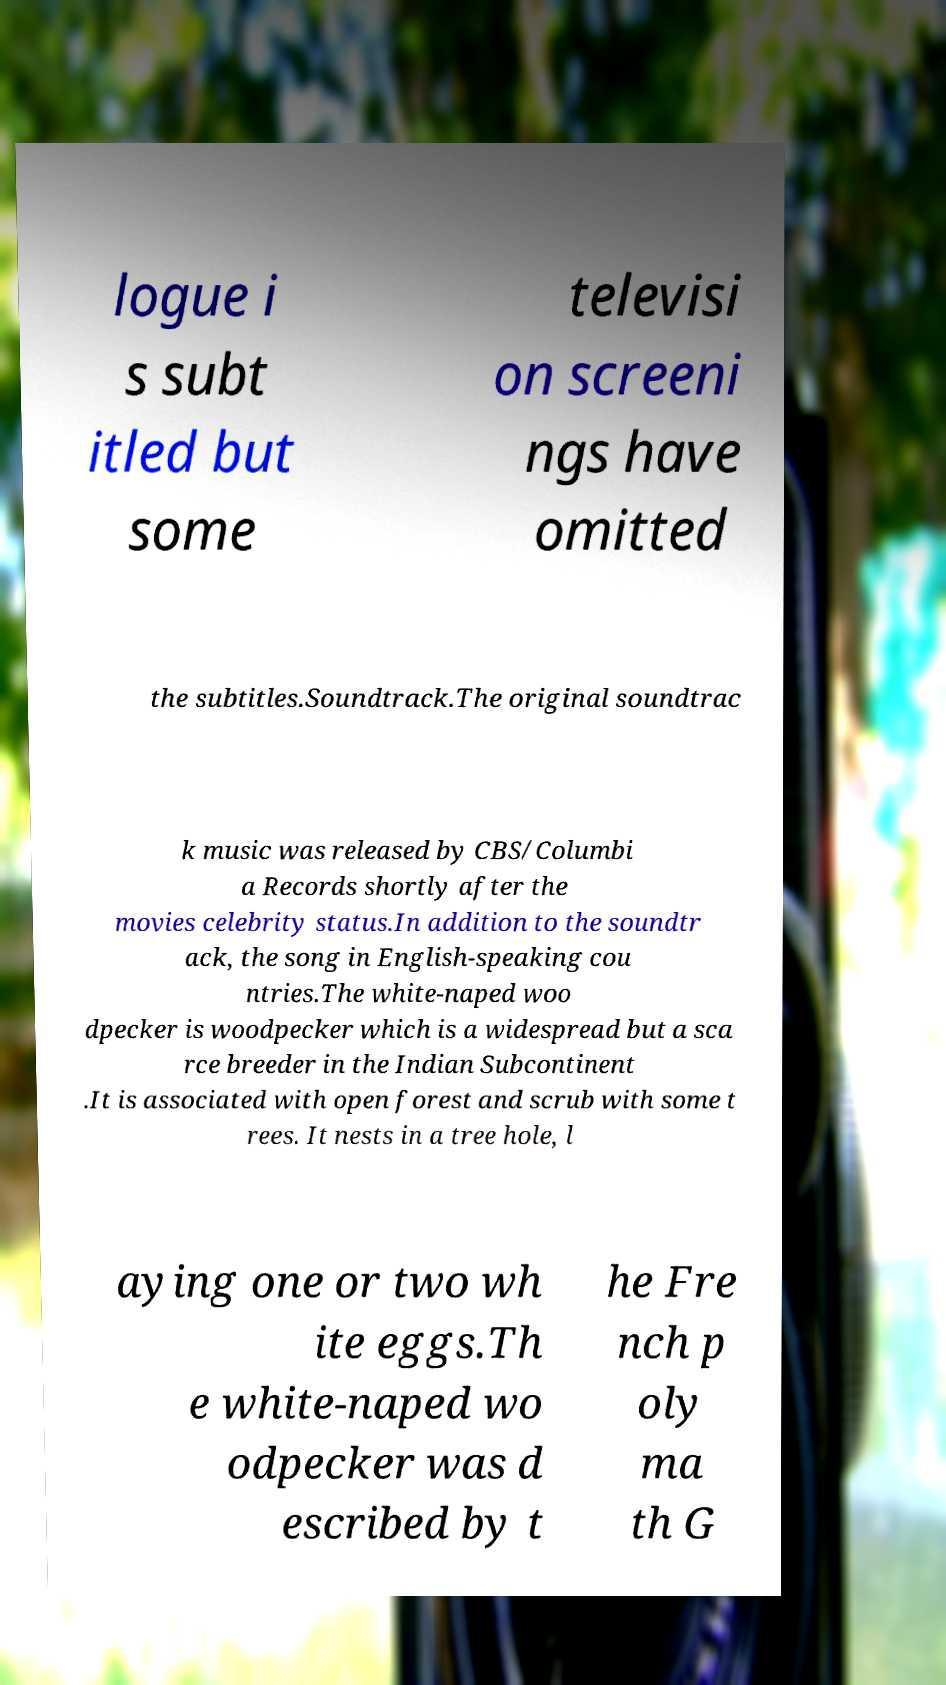Please identify and transcribe the text found in this image. logue i s subt itled but some televisi on screeni ngs have omitted the subtitles.Soundtrack.The original soundtrac k music was released by CBS/Columbi a Records shortly after the movies celebrity status.In addition to the soundtr ack, the song in English-speaking cou ntries.The white-naped woo dpecker is woodpecker which is a widespread but a sca rce breeder in the Indian Subcontinent .It is associated with open forest and scrub with some t rees. It nests in a tree hole, l aying one or two wh ite eggs.Th e white-naped wo odpecker was d escribed by t he Fre nch p oly ma th G 